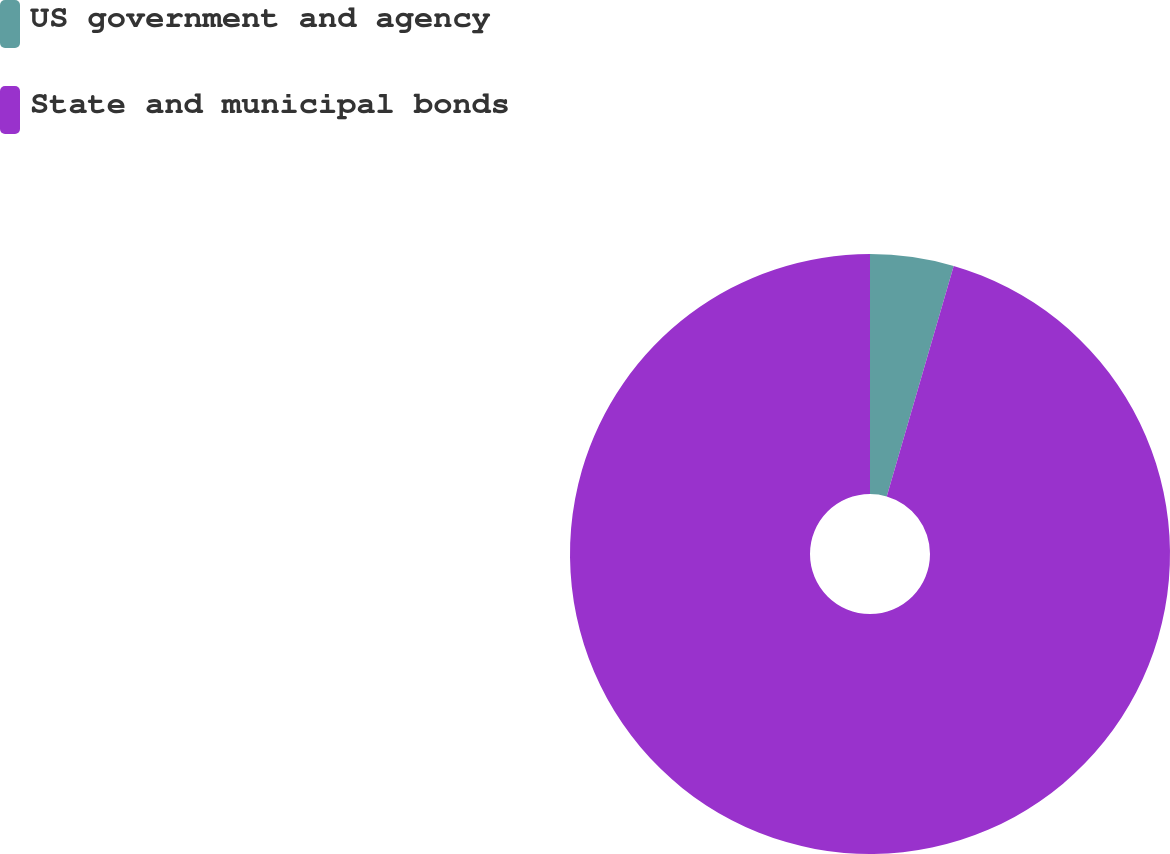<chart> <loc_0><loc_0><loc_500><loc_500><pie_chart><fcel>US government and agency<fcel>State and municipal bonds<nl><fcel>4.5%<fcel>95.5%<nl></chart> 